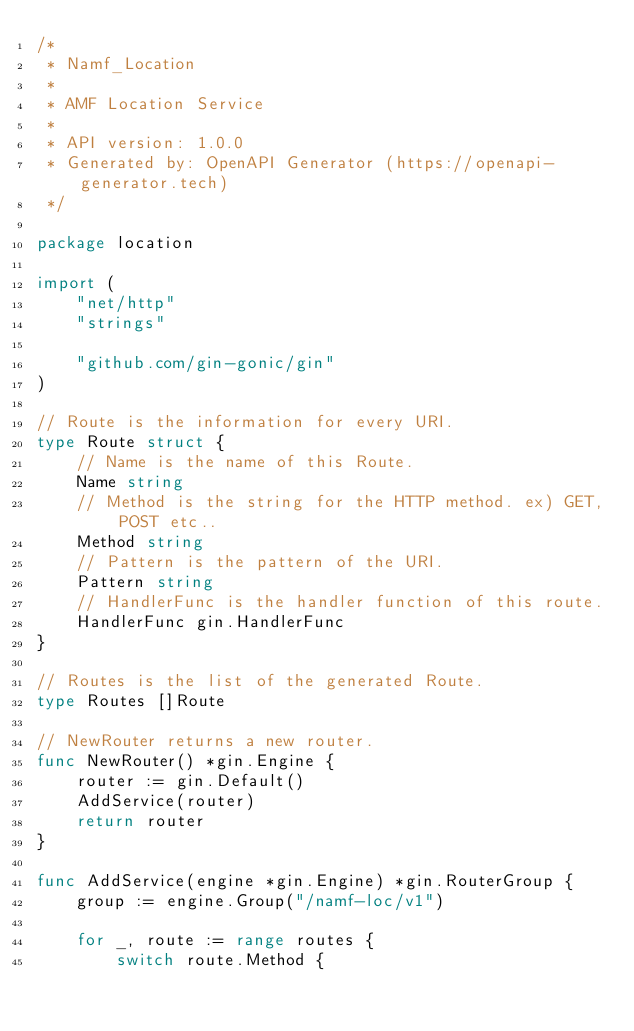<code> <loc_0><loc_0><loc_500><loc_500><_Go_>/*
 * Namf_Location
 *
 * AMF Location Service
 *
 * API version: 1.0.0
 * Generated by: OpenAPI Generator (https://openapi-generator.tech)
 */

package location

import (
	"net/http"
	"strings"

	"github.com/gin-gonic/gin"
)

// Route is the information for every URI.
type Route struct {
	// Name is the name of this Route.
	Name string
	// Method is the string for the HTTP method. ex) GET, POST etc..
	Method string
	// Pattern is the pattern of the URI.
	Pattern string
	// HandlerFunc is the handler function of this route.
	HandlerFunc gin.HandlerFunc
}

// Routes is the list of the generated Route.
type Routes []Route

// NewRouter returns a new router.
func NewRouter() *gin.Engine {
	router := gin.Default()
	AddService(router)
	return router
}

func AddService(engine *gin.Engine) *gin.RouterGroup {
	group := engine.Group("/namf-loc/v1")

	for _, route := range routes {
		switch route.Method {</code> 